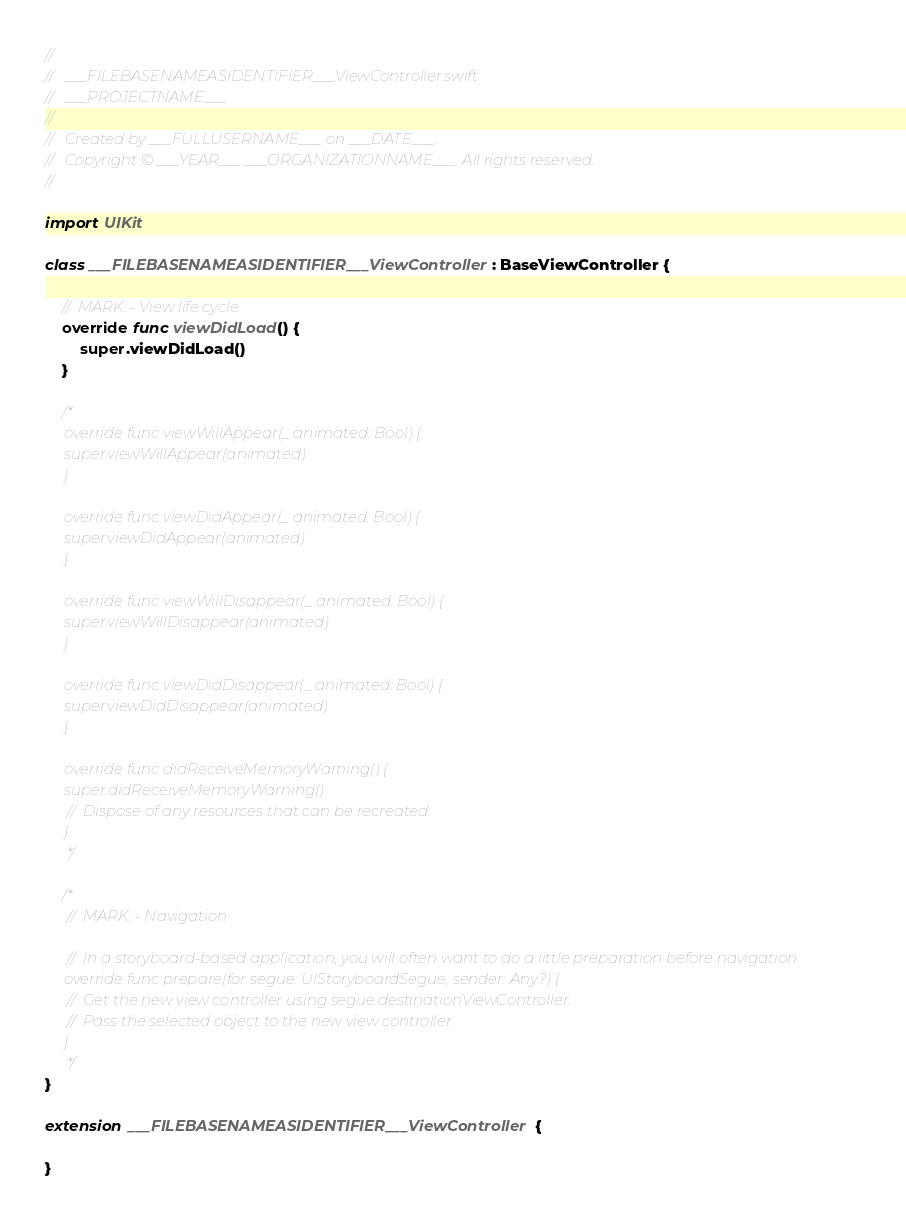<code> <loc_0><loc_0><loc_500><loc_500><_Swift_>//
//  ___FILEBASENAMEASIDENTIFIER___ViewController.swift
//  ___PROJECTNAME___
//
//  Created by ___FULLUSERNAME___ on ___DATE___.
//  Copyright © ___YEAR___ ___ORGANIZATIONNAME___. All rights reserved.
//

import UIKit

class ___FILEBASENAMEASIDENTIFIER___ViewController: BaseViewController {
    
    // MARK: - View life cycle
    override func viewDidLoad() {
        super.viewDidLoad()
    }
    
    /*
     override func viewWillAppear(_ animated: Bool) {
     super.viewWillAppear(animated)
     }
     
     override func viewDidAppear(_ animated: Bool) {
     super.viewDidAppear(animated)
     }
     
     override func viewWillDisappear(_ animated: Bool) {
     super.viewWillDisappear(animated)
     }
     
     override func viewDidDisappear(_ animated: Bool) {
     super.viewDidDisappear(animated)
     }
     
     override func didReceiveMemoryWarning() {
     super.didReceiveMemoryWarning()
     // Dispose of any resources that can be recreated.
     }
     */
    
    /*
     // MARK: - Navigation
     
     // In a storyboard-based application, you will often want to do a little preparation before navigation
     override func prepare(for segue: UIStoryboardSegue, sender: Any?) {
     // Get the new view controller using segue.destinationViewController.
     // Pass the selected object to the new view controller.
     }
     */
}

extension ___FILEBASENAMEASIDENTIFIER___ViewController {
    
}
</code> 